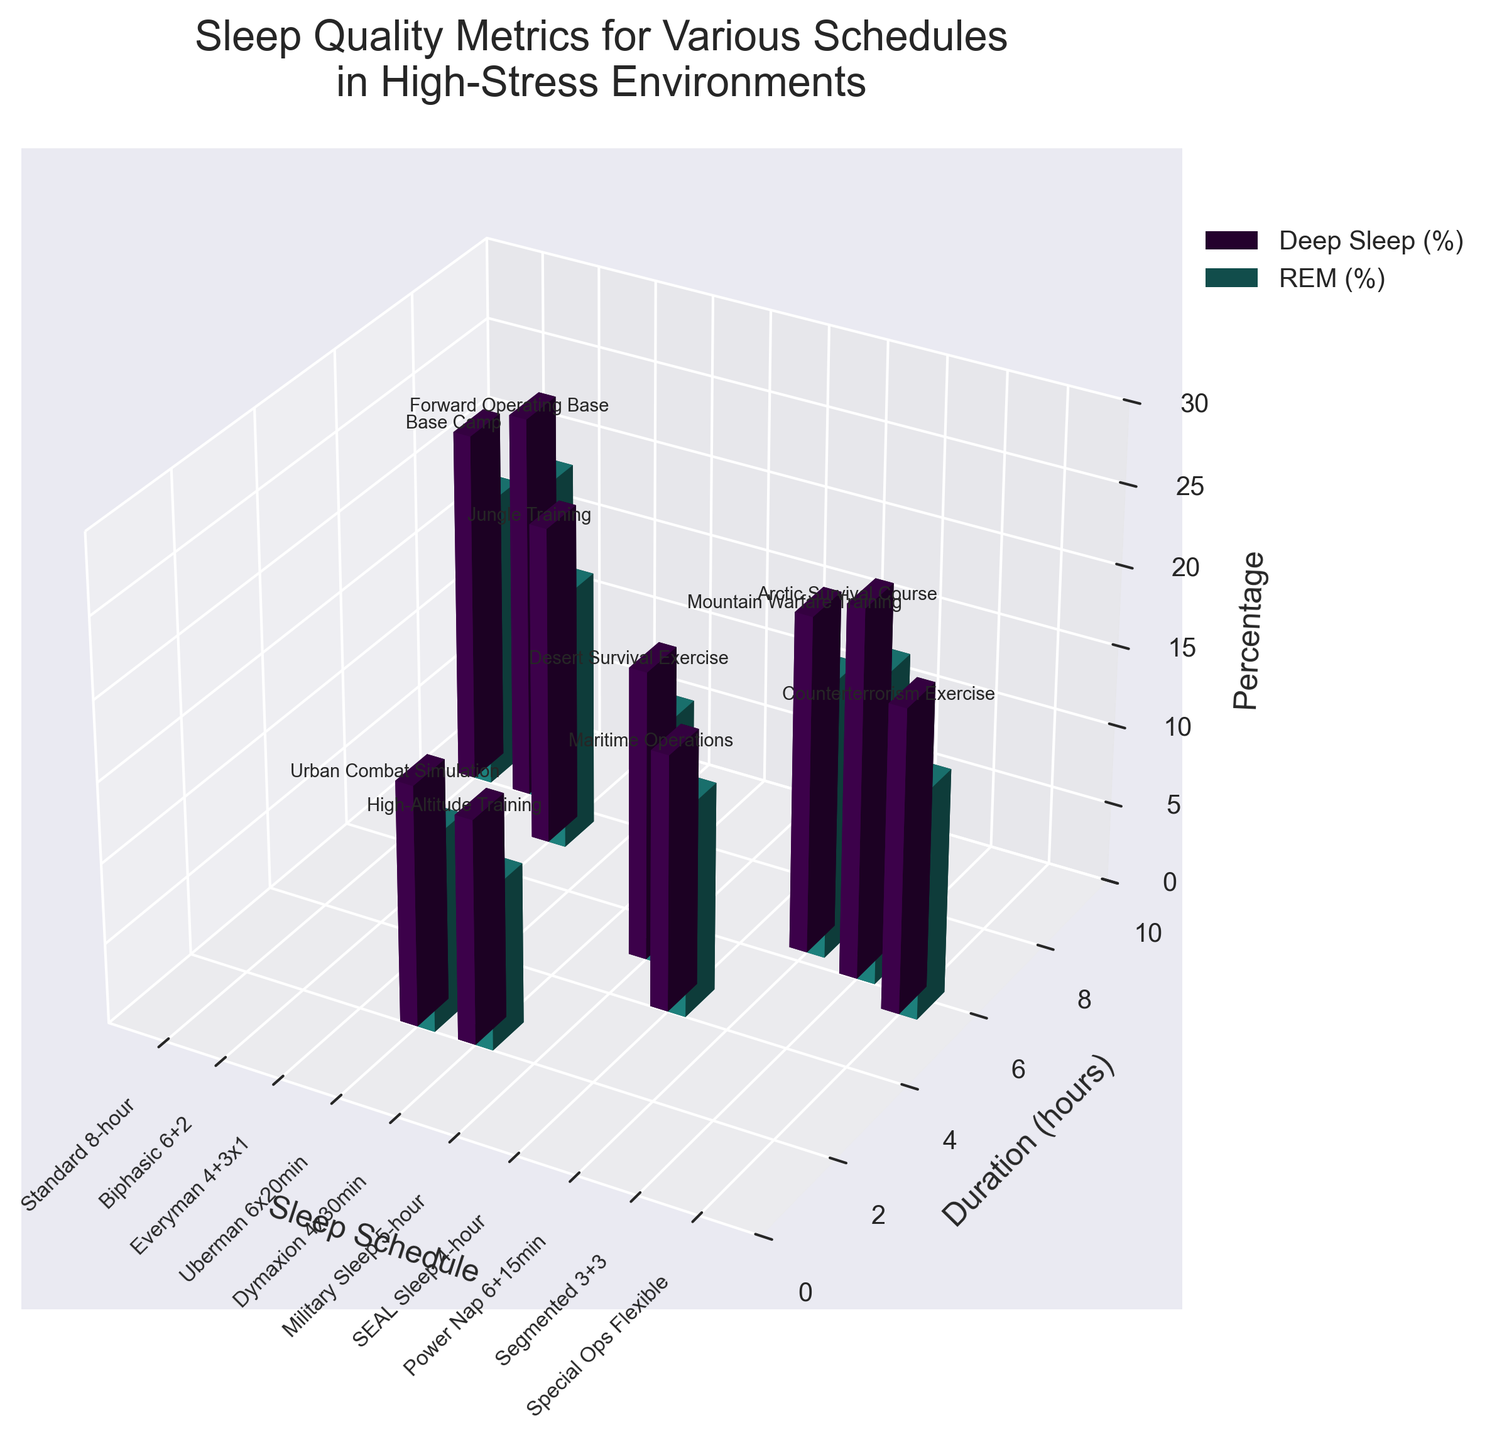What is the title of the figure? The title is typically found at the top of the figure and usually describes the content being visualized. It provides a high-level understanding of what the figure is about.
Answer: Sleep Quality Metrics for Various Schedules in High-Stress Environments How many sleep schedules are compared in the figure? To find the number of sleep schedules, count the distinct labels on the x-axis of the figure. These labels represent the different sleep schedules being evaluated.
Answer: 10 Which sleep schedule has the highest deep sleep percentage, and what is the percentage? To determine this, examine the height of the Deep Sleep (%) bars for each schedule. Identify the tallest bar and read off the corresponding percentage value.
Answer: Biphasic 6+2, 24% Comparing Military Sleep and Standard 8-hour, which one has a higher REM percentage, and what are those percentages? Look at the height of the REM (%) bars for Military Sleep and Standard 8-hour schedules. By comparing the heights, you can identify which is higher and their respective values.
Answer: Standard 8-hour has 18%, Military Sleep has 15% What is the sum of the duration (hours) and deep sleep (%) for the SEAL Sleep schedule? First, find the duration for SEAL Sleep and the deep sleep percentage. Add these two values together to get the sum.
Answer: Duration (4 hours) + Deep Sleep (16%) = 20 Which sleep schedule has the shortest duration, and what is its deep sleep percentage? Identify the schedule with the shortest bar on the Duration axis. Then, find the corresponding deep sleep percentage for that schedule.
Answer: Uberman 6x20min, 15% What is the average REM percentage across all the sleep schedules? To find the average, add up the REM percentages for all sleep schedules and divide by the number of schedules.
Answer: (18 + 20 + 16 + 12 + 10 + 15 + 13 + 17 + 19 + 14) / 10 = 15.4% Which environment corresponds to the Segmented 3+3 sleep schedule? Look for the label text associated with the Segmented 3+3 schedule to find the environment. These labels are typically placed near the bars.
Answer: Arctic Survival Course Are there any sleep schedules with the same duration but different deep sleep and REM percentages? Examine the Duration bars for schedules with identical lengths, then compare their Deep Sleep and REM bars to see if they differ.
Answer: Standard 8-hour and Biphasic 6+2 (both 8 hours) but different deep sleep and REM percentages Which schedule in the Counterterrorism Exercise environment, and what are its duration and REM percentage? Look for the environment label first, then identify the corresponding schedule and read off the duration and REM percentage.
Answer: Special Ops Flexible, Duration 5.5 hours, REM 14% 